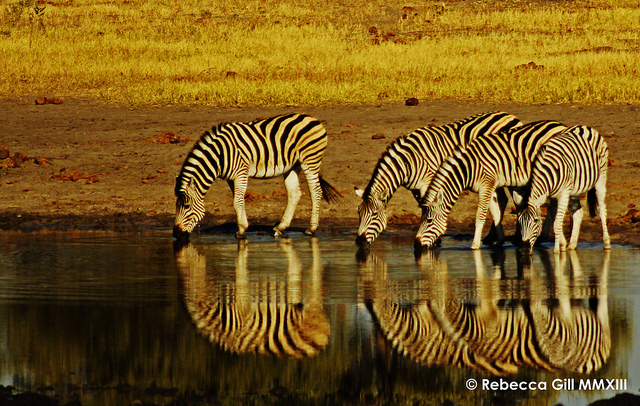Please extract the text content from this image. Rebecca Gill MMXIII &#169; 